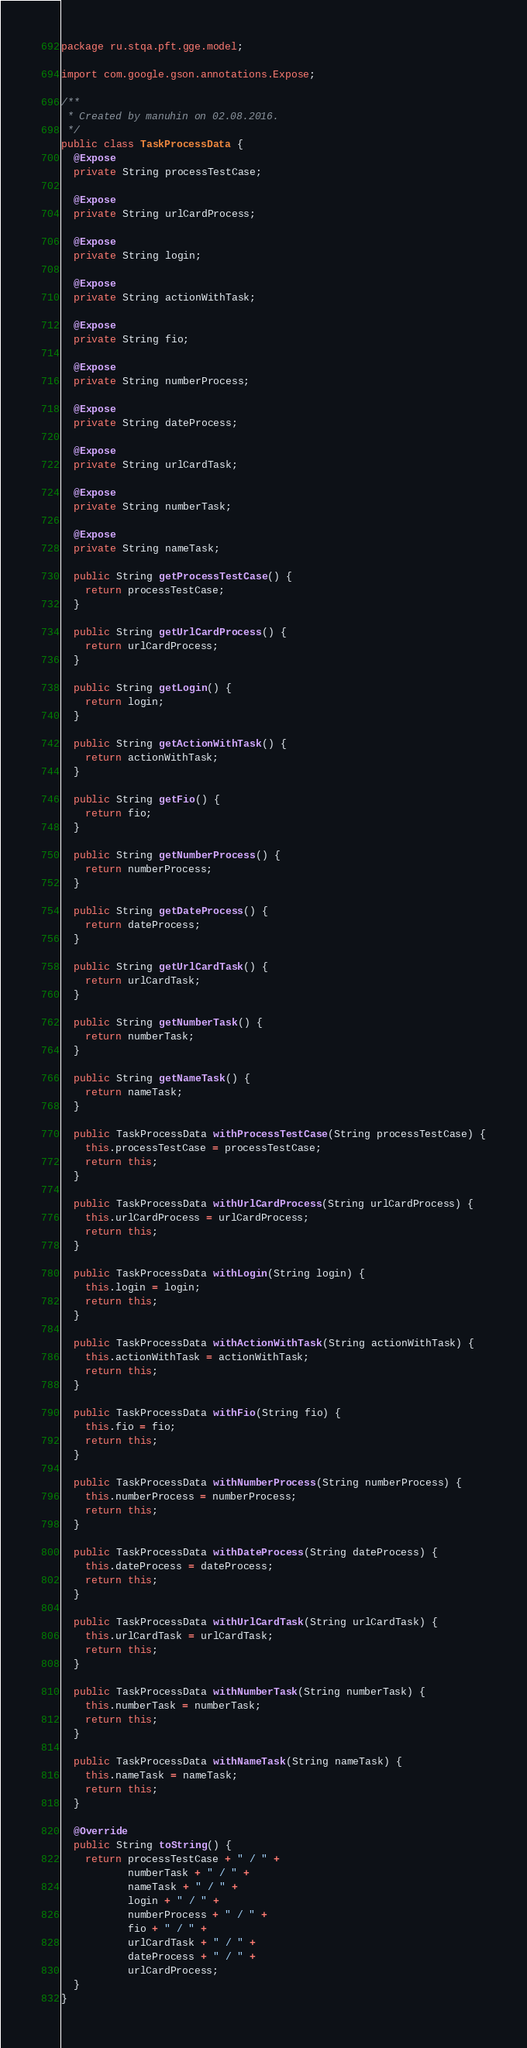Convert code to text. <code><loc_0><loc_0><loc_500><loc_500><_Java_>package ru.stqa.pft.gge.model;

import com.google.gson.annotations.Expose;

/**
 * Created by manuhin on 02.08.2016.
 */
public class TaskProcessData {
  @Expose
  private String processTestCase;

  @Expose
  private String urlCardProcess;

  @Expose
  private String login;

  @Expose
  private String actionWithTask;

  @Expose
  private String fio;

  @Expose
  private String numberProcess;

  @Expose
  private String dateProcess;

  @Expose
  private String urlCardTask;

  @Expose
  private String numberTask;

  @Expose
  private String nameTask;

  public String getProcessTestCase() {
    return processTestCase;
  }

  public String getUrlCardProcess() {
    return urlCardProcess;
  }

  public String getLogin() {
    return login;
  }

  public String getActionWithTask() {
    return actionWithTask;
  }

  public String getFio() {
    return fio;
  }

  public String getNumberProcess() {
    return numberProcess;
  }

  public String getDateProcess() {
    return dateProcess;
  }

  public String getUrlCardTask() {
    return urlCardTask;
  }

  public String getNumberTask() {
    return numberTask;
  }

  public String getNameTask() {
    return nameTask;
  }

  public TaskProcessData withProcessTestCase(String processTestCase) {
    this.processTestCase = processTestCase;
    return this;
  }

  public TaskProcessData withUrlCardProcess(String urlCardProcess) {
    this.urlCardProcess = urlCardProcess;
    return this;
  }

  public TaskProcessData withLogin(String login) {
    this.login = login;
    return this;
  }

  public TaskProcessData withActionWithTask(String actionWithTask) {
    this.actionWithTask = actionWithTask;
    return this;
  }

  public TaskProcessData withFio(String fio) {
    this.fio = fio;
    return this;
  }

  public TaskProcessData withNumberProcess(String numberProcess) {
    this.numberProcess = numberProcess;
    return this;
  }

  public TaskProcessData withDateProcess(String dateProcess) {
    this.dateProcess = dateProcess;
    return this;
  }

  public TaskProcessData withUrlCardTask(String urlCardTask) {
    this.urlCardTask = urlCardTask;
    return this;
  }

  public TaskProcessData withNumberTask(String numberTask) {
    this.numberTask = numberTask;
    return this;
  }

  public TaskProcessData withNameTask(String nameTask) {
    this.nameTask = nameTask;
    return this;
  }

  @Override
  public String toString() {
    return processTestCase + " / " +
           numberTask + " / " +
           nameTask + " / " +
           login + " / " +
           numberProcess + " / " +
           fio + " / " +
           urlCardTask + " / " +
           dateProcess + " / " +
           urlCardProcess;
  }
}
</code> 